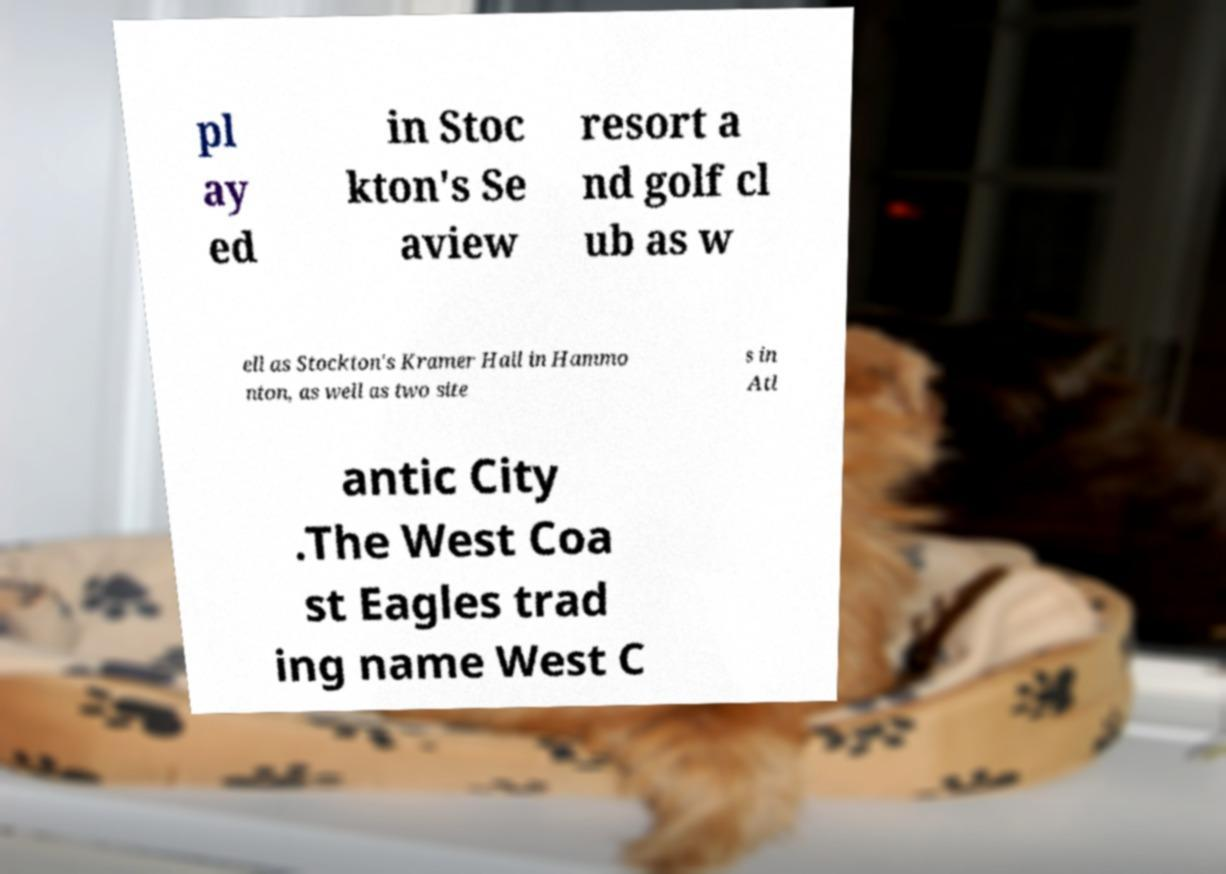Can you accurately transcribe the text from the provided image for me? pl ay ed in Stoc kton's Se aview resort a nd golf cl ub as w ell as Stockton's Kramer Hall in Hammo nton, as well as two site s in Atl antic City .The West Coa st Eagles trad ing name West C 